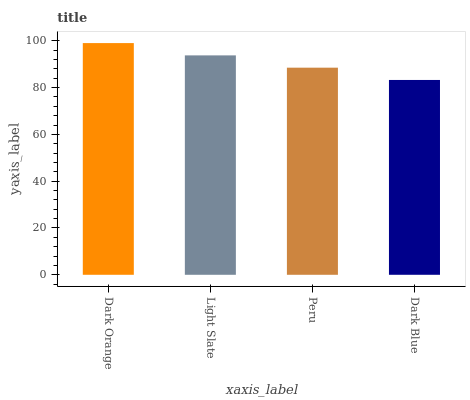Is Dark Blue the minimum?
Answer yes or no. Yes. Is Dark Orange the maximum?
Answer yes or no. Yes. Is Light Slate the minimum?
Answer yes or no. No. Is Light Slate the maximum?
Answer yes or no. No. Is Dark Orange greater than Light Slate?
Answer yes or no. Yes. Is Light Slate less than Dark Orange?
Answer yes or no. Yes. Is Light Slate greater than Dark Orange?
Answer yes or no. No. Is Dark Orange less than Light Slate?
Answer yes or no. No. Is Light Slate the high median?
Answer yes or no. Yes. Is Peru the low median?
Answer yes or no. Yes. Is Dark Orange the high median?
Answer yes or no. No. Is Dark Blue the low median?
Answer yes or no. No. 